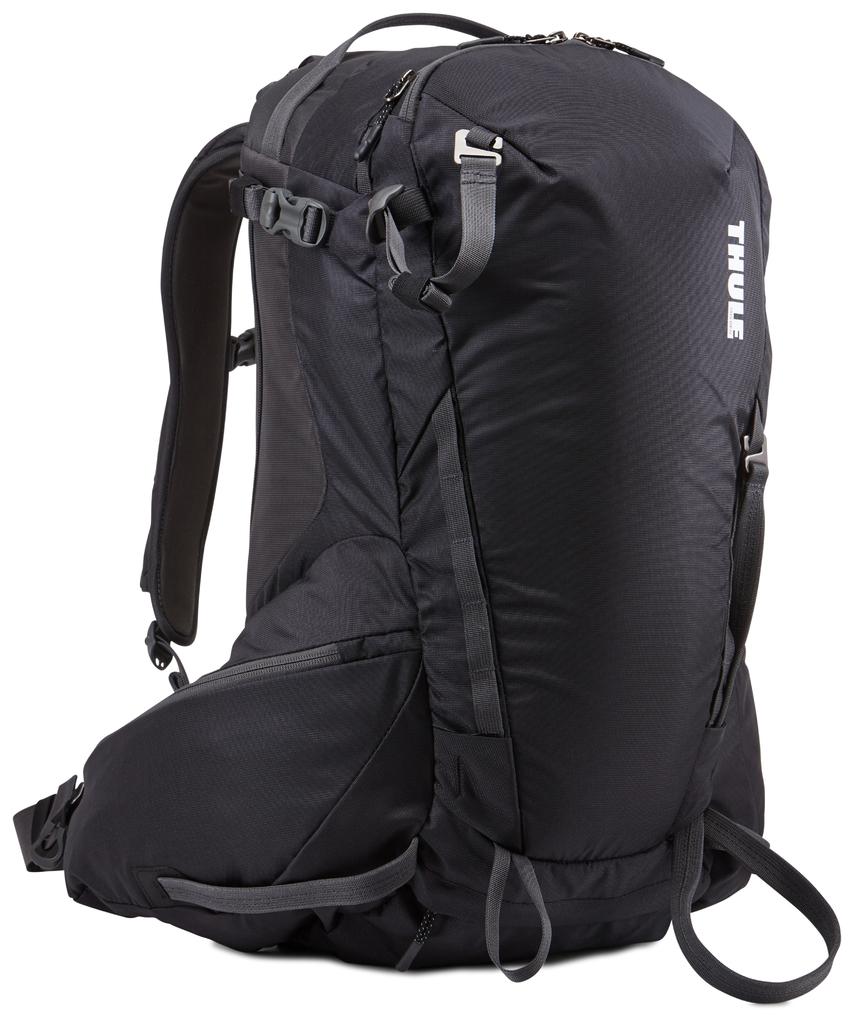What brand is the bag?
Give a very brief answer. Thule. 